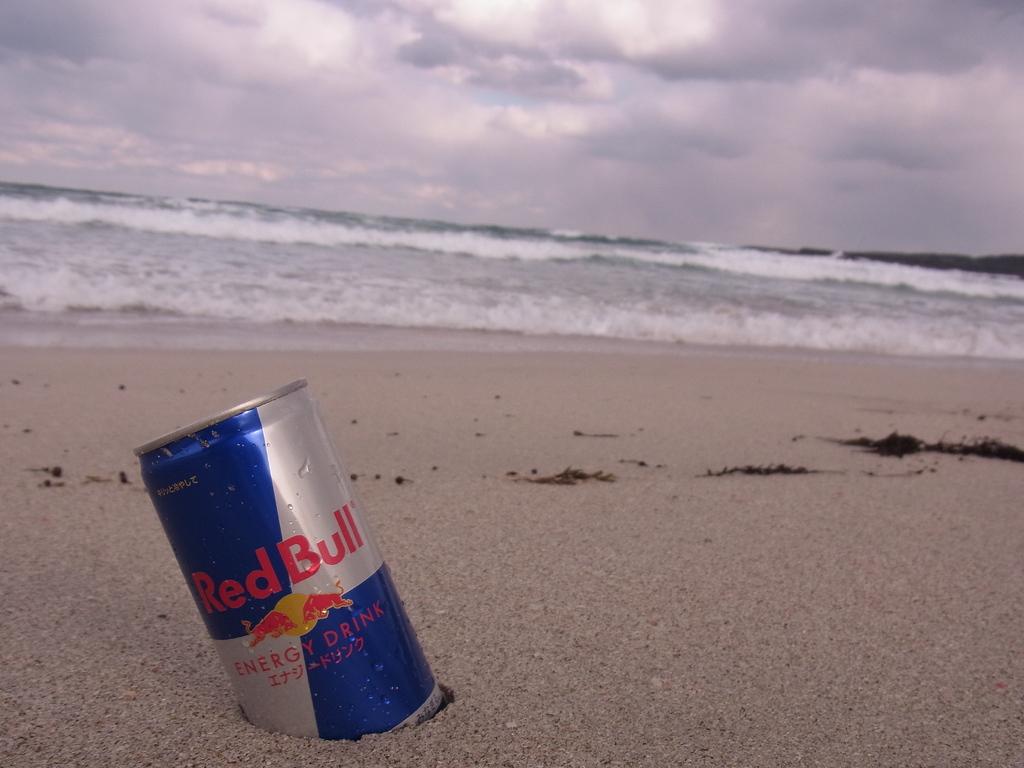What kind of drink is this?
Provide a succinct answer. Red bull. 